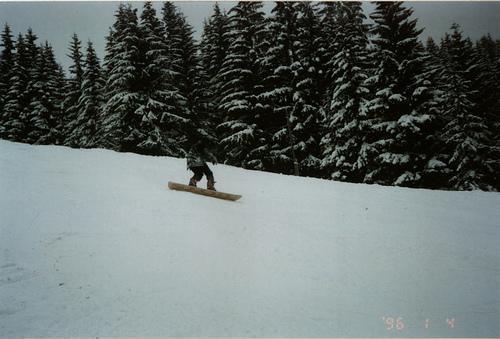How many people are there?
Give a very brief answer. 1. How many buses are in the picture?
Give a very brief answer. 0. 